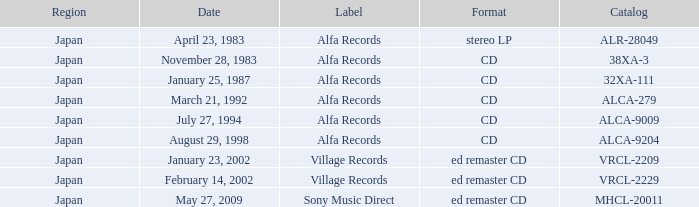Which region is identified as 38xa-3 in the catalog? Japan. 